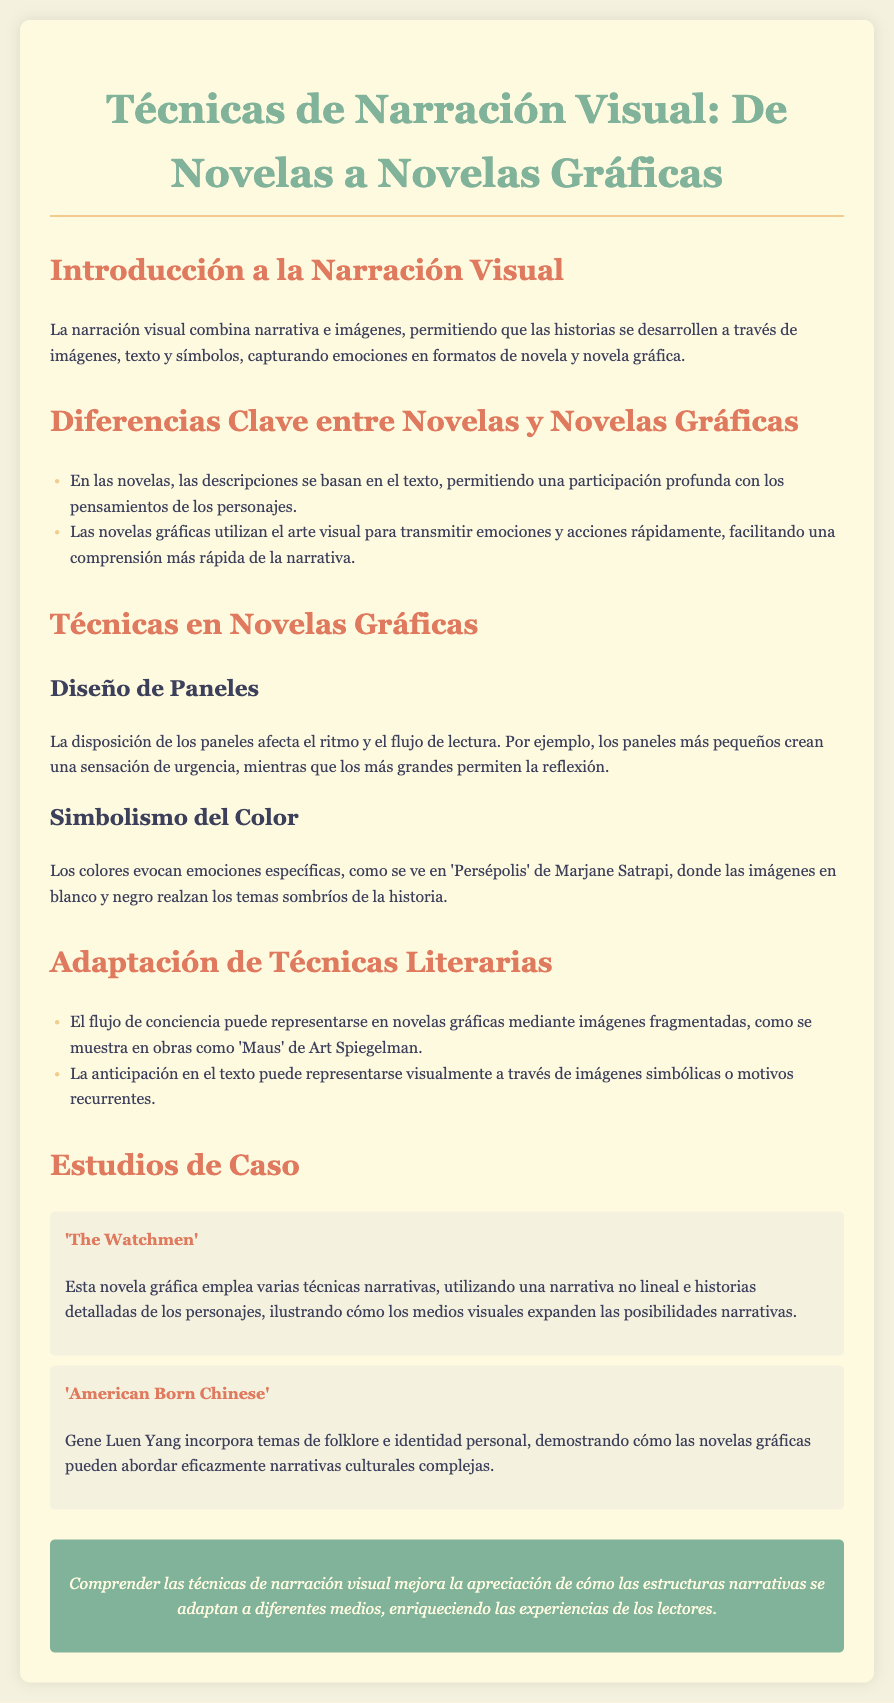¿Cuál es el título del documento? El título del documento es el encabezado principal que se encuentra al inicio del texto.
Answer: Técnicas de Narración Visual: De Novelas a Novelas Gráficas ¿Qué se combina en la narración visual? La narración visual combina dos elementos principales que permiten contar una historia de manera visual.
Answer: narrativa e imágenes ¿Qué técnica afecta el ritmo de lectura en novelas gráficas? Se menciona una técnica específica que influencia cómo se desarrolla la lectura en este tipo de obras.
Answer: Diseño de Paneles ¿Cuál es un ejemplo de una novela gráfica mencionada? El documento cita dos ejemplos de novelas gráficas en los estudios de caso, nombrando una de ellas.
Answer: The Watchmen ¿Qué color se utiliza en 'Persépolis' para realzar temas sombríos? Esta novela gráfica utiliza un esquema de color específico para transmitir ciertos temas emocionales.
Answer: blanco y negro ¿Cómo se representa el flujo de conciencia en las novelas gráficas? Se menciona una forma en que se puede expresar esta técnica literaria en el contexto de novelas gráficas.
Answer: imágenes fragmentadas ¿Cuál es el propósito de conocer técnicas de narración visual? En la conclusión se indica un beneficio específico de entender estas técnicas en la apreciación de la narrativa.
Answer: mejorar la apreciación ¿Cómo aborda 'American Born Chinese' temas complejos? Se señala que esta novela gráfica trata ciertos temas mediante un enfoque específico dentro de su narrativa.
Answer: folklore e identidad personal 